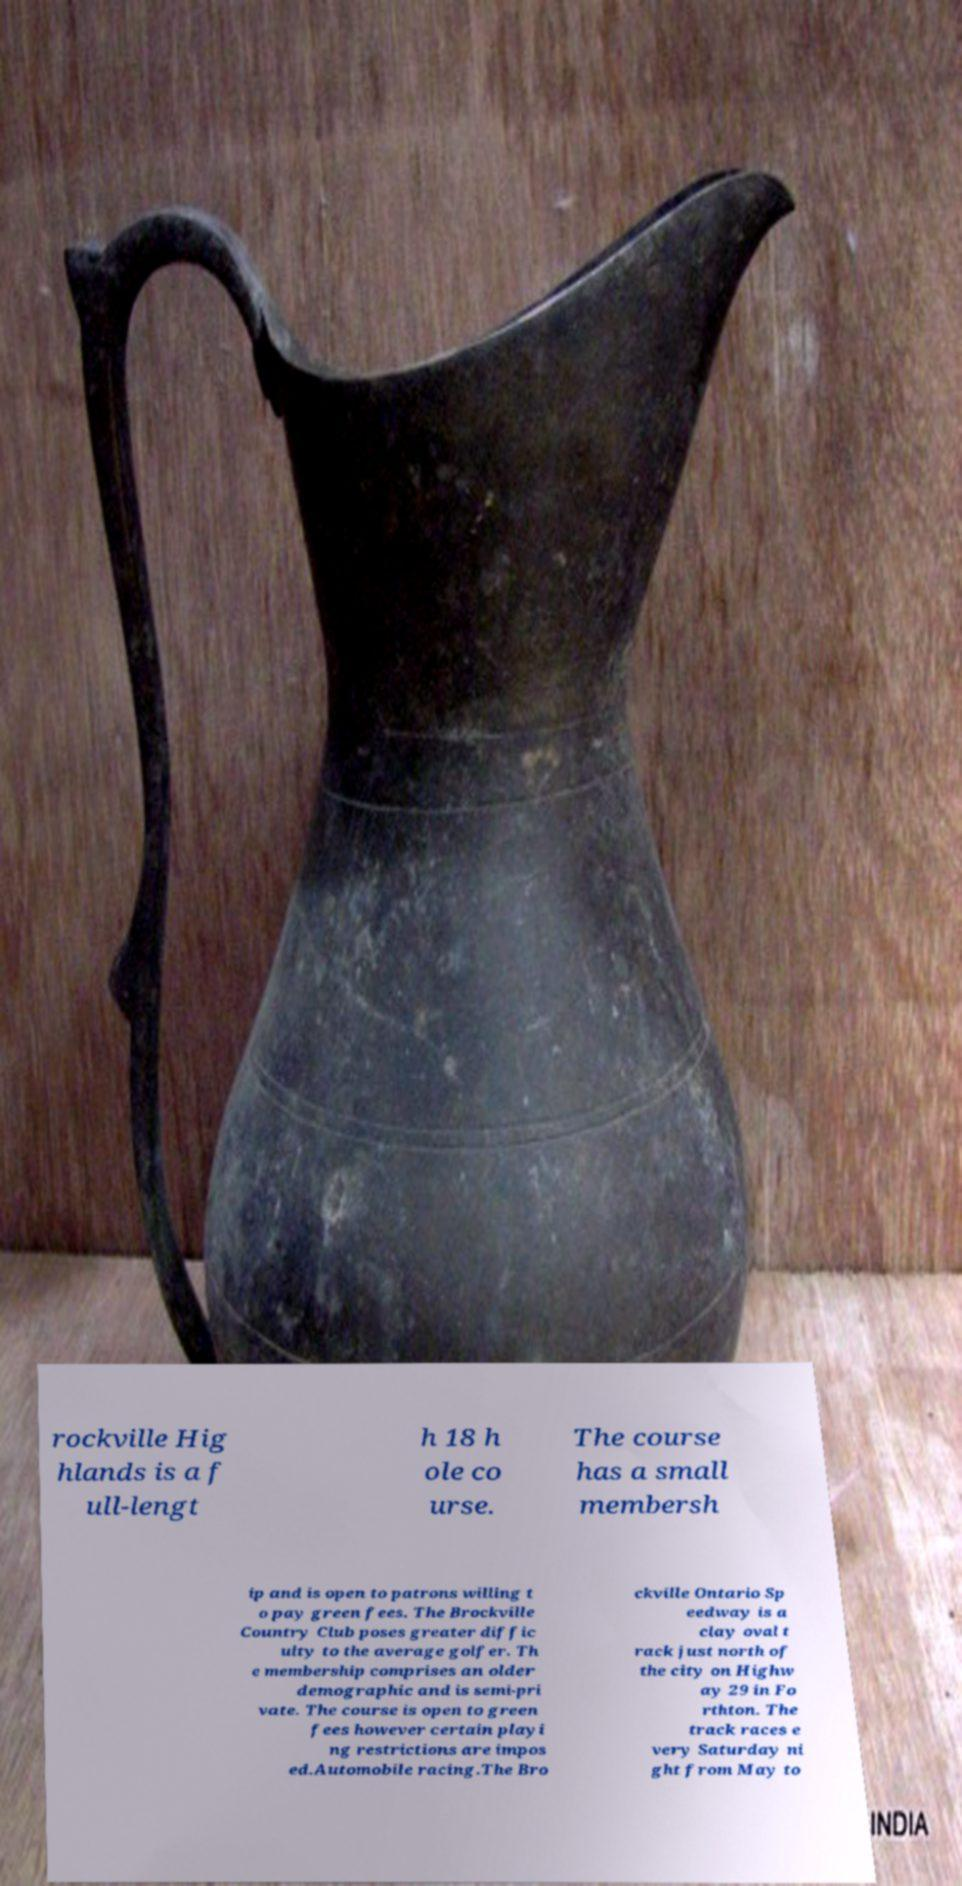Please read and relay the text visible in this image. What does it say? rockville Hig hlands is a f ull-lengt h 18 h ole co urse. The course has a small membersh ip and is open to patrons willing t o pay green fees. The Brockville Country Club poses greater diffic ulty to the average golfer. Th e membership comprises an older demographic and is semi-pri vate. The course is open to green fees however certain playi ng restrictions are impos ed.Automobile racing.The Bro ckville Ontario Sp eedway is a clay oval t rack just north of the city on Highw ay 29 in Fo rthton. The track races e very Saturday ni ght from May to 